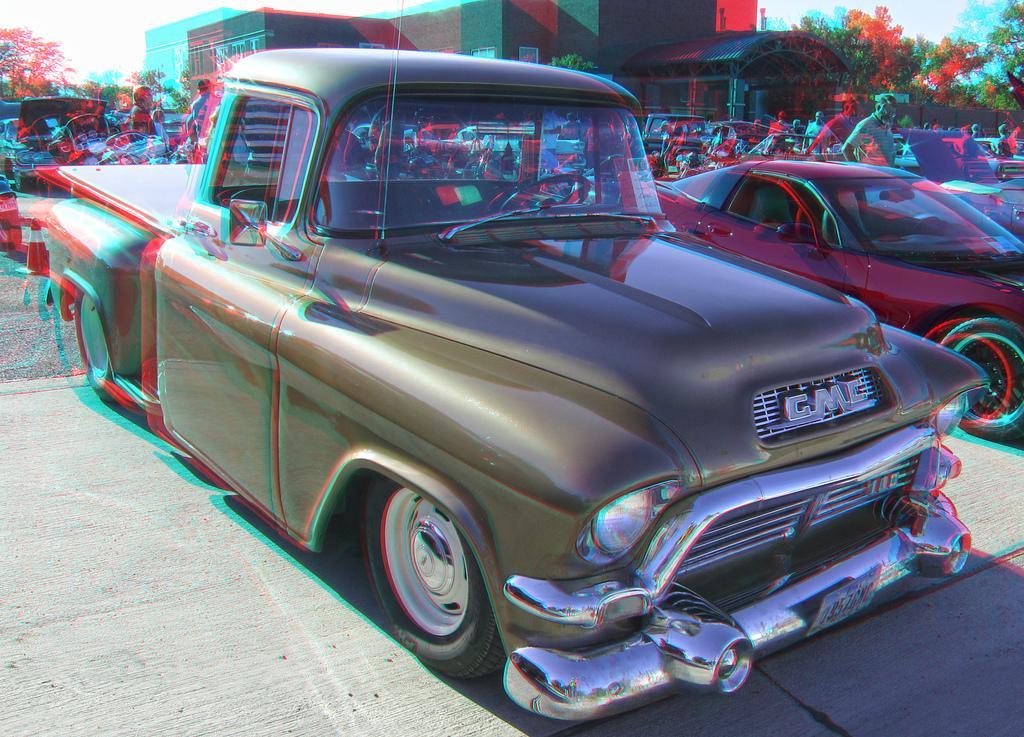In one or two sentences, can you explain what this image depicts? In this picture I can observe some cars parked on the road. There is a building and some trees in the background. I can observe some people on the road. 